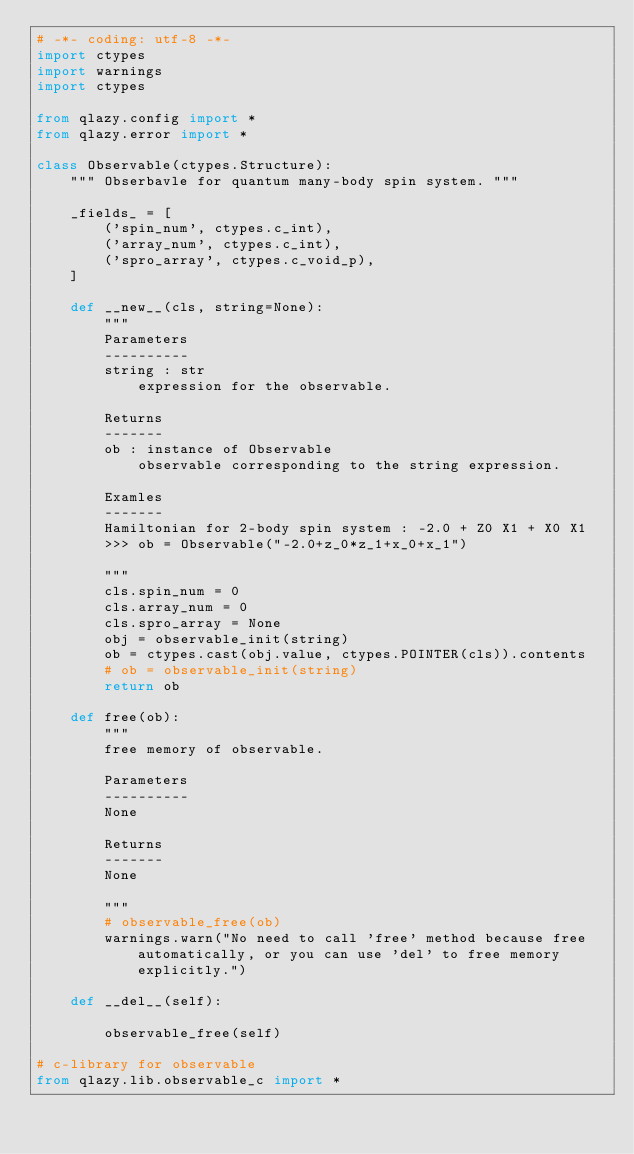Convert code to text. <code><loc_0><loc_0><loc_500><loc_500><_Python_># -*- coding: utf-8 -*-
import ctypes
import warnings
import ctypes

from qlazy.config import *
from qlazy.error import *

class Observable(ctypes.Structure):
    """ Obserbavle for quantum many-body spin system. """
    
    _fields_ = [
        ('spin_num', ctypes.c_int),
        ('array_num', ctypes.c_int),
        ('spro_array', ctypes.c_void_p),
    ]

    def __new__(cls, string=None):
        """
        Parameters
        ----------
        string : str
            expression for the observable.

        Returns
        -------
        ob : instance of Observable
            observable corresponding to the string expression.

        Examles
        -------
        Hamiltonian for 2-body spin system : -2.0 + Z0 X1 + X0 X1
        >>> ob = Observable("-2.0+z_0*z_1+x_0+x_1")

        """
        cls.spin_num = 0
        cls.array_num = 0
        cls.spro_array = None
        obj = observable_init(string)
        ob = ctypes.cast(obj.value, ctypes.POINTER(cls)).contents
        # ob = observable_init(string)
        return ob

    def free(ob):
        """
        free memory of observable.

        Parameters
        ----------
        None

        Returns
        -------
        None

        """
        # observable_free(ob)
        warnings.warn("No need to call 'free' method because free automatically, or you can use 'del' to free memory explicitly.")

    def __del__(self):
        
        observable_free(self)

# c-library for observable
from qlazy.lib.observable_c import *
</code> 